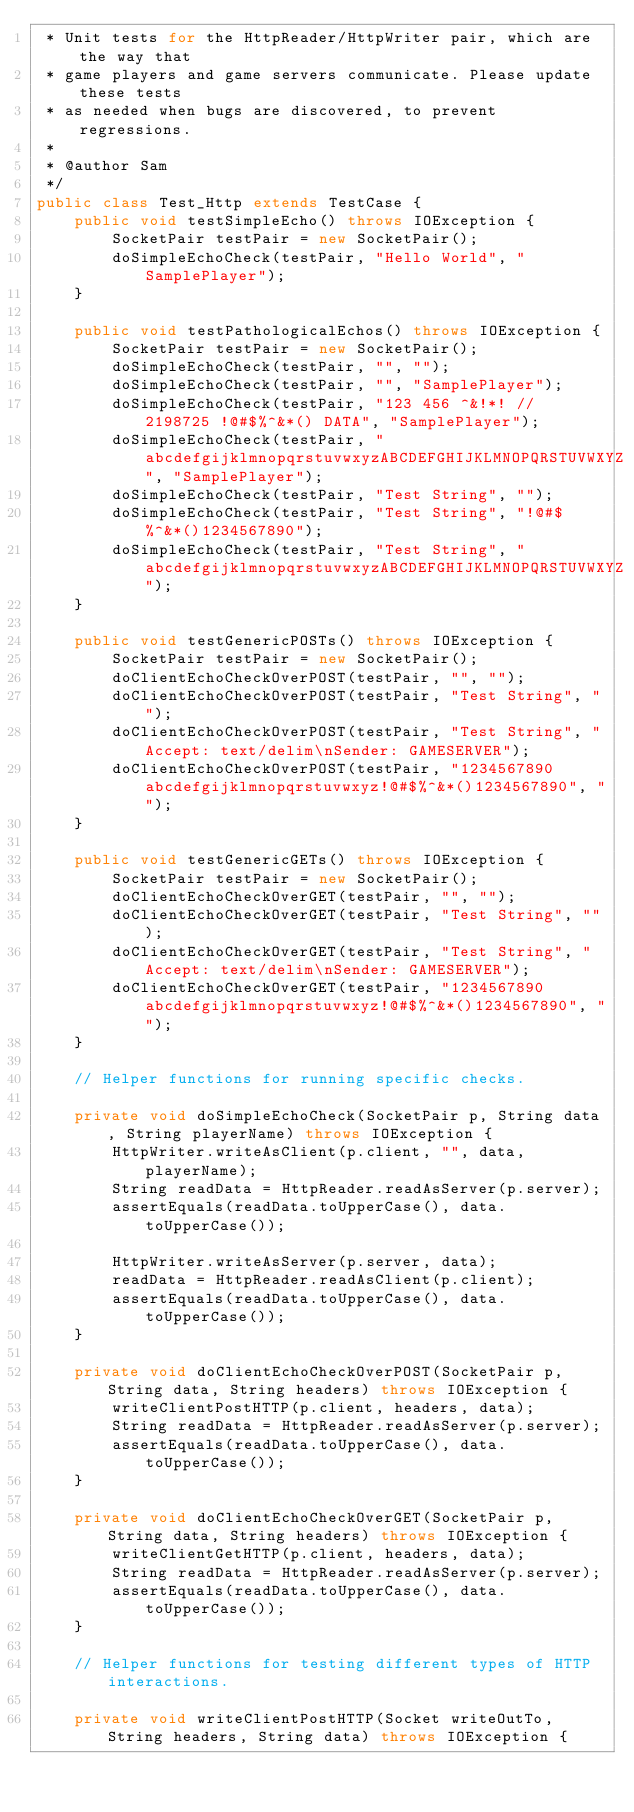Convert code to text. <code><loc_0><loc_0><loc_500><loc_500><_Java_> * Unit tests for the HttpReader/HttpWriter pair, which are the way that
 * game players and game servers communicate. Please update these tests
 * as needed when bugs are discovered, to prevent regressions.
 *
 * @author Sam
 */
public class Test_Http extends TestCase {
    public void testSimpleEcho() throws IOException {
        SocketPair testPair = new SocketPair();
        doSimpleEchoCheck(testPair, "Hello World", "SamplePlayer");
    }

    public void testPathologicalEchos() throws IOException {
        SocketPair testPair = new SocketPair();
        doSimpleEchoCheck(testPair, "", "");
        doSimpleEchoCheck(testPair, "", "SamplePlayer");
        doSimpleEchoCheck(testPair, "123 456 ^&!*! // 2198725 !@#$%^&*() DATA", "SamplePlayer");
        doSimpleEchoCheck(testPair, "abcdefgijklmnopqrstuvwxyzABCDEFGHIJKLMNOPQRSTUVWXYZ", "SamplePlayer");
        doSimpleEchoCheck(testPair, "Test String", "");
        doSimpleEchoCheck(testPair, "Test String", "!@#$%^&*()1234567890");
        doSimpleEchoCheck(testPair, "Test String", "abcdefgijklmnopqrstuvwxyzABCDEFGHIJKLMNOPQRSTUVWXYZ");
    }

    public void testGenericPOSTs() throws IOException {
        SocketPair testPair = new SocketPair();
        doClientEchoCheckOverPOST(testPair, "", "");
        doClientEchoCheckOverPOST(testPair, "Test String", "");
        doClientEchoCheckOverPOST(testPair, "Test String", "Accept: text/delim\nSender: GAMESERVER");
        doClientEchoCheckOverPOST(testPair, "1234567890abcdefgijklmnopqrstuvwxyz!@#$%^&*()1234567890", "");
    }

    public void testGenericGETs() throws IOException {
        SocketPair testPair = new SocketPair();
        doClientEchoCheckOverGET(testPair, "", "");
        doClientEchoCheckOverGET(testPair, "Test String", "");
        doClientEchoCheckOverGET(testPair, "Test String", "Accept: text/delim\nSender: GAMESERVER");
        doClientEchoCheckOverGET(testPair, "1234567890abcdefgijklmnopqrstuvwxyz!@#$%^&*()1234567890", "");
    }

    // Helper functions for running specific checks.

    private void doSimpleEchoCheck(SocketPair p, String data, String playerName) throws IOException {
        HttpWriter.writeAsClient(p.client, "", data, playerName);
        String readData = HttpReader.readAsServer(p.server);
        assertEquals(readData.toUpperCase(), data.toUpperCase());

        HttpWriter.writeAsServer(p.server, data);
        readData = HttpReader.readAsClient(p.client);
        assertEquals(readData.toUpperCase(), data.toUpperCase());
    }

    private void doClientEchoCheckOverPOST(SocketPair p, String data, String headers) throws IOException {
        writeClientPostHTTP(p.client, headers, data);
        String readData = HttpReader.readAsServer(p.server);
        assertEquals(readData.toUpperCase(), data.toUpperCase());
    }

    private void doClientEchoCheckOverGET(SocketPair p, String data, String headers) throws IOException {
        writeClientGetHTTP(p.client, headers, data);
        String readData = HttpReader.readAsServer(p.server);
        assertEquals(readData.toUpperCase(), data.toUpperCase());
    }

    // Helper functions for testing different types of HTTP interactions.

    private void writeClientPostHTTP(Socket writeOutTo, String headers, String data) throws IOException {</code> 